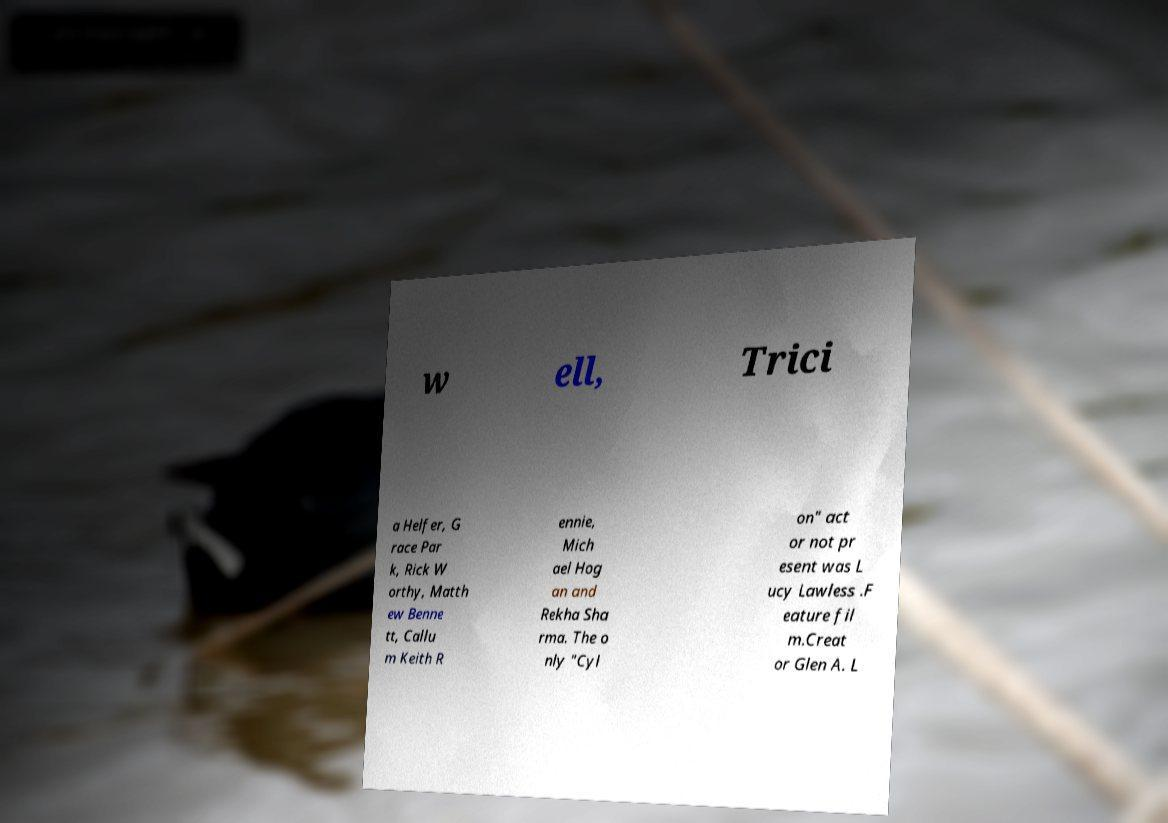Can you accurately transcribe the text from the provided image for me? w ell, Trici a Helfer, G race Par k, Rick W orthy, Matth ew Benne tt, Callu m Keith R ennie, Mich ael Hog an and Rekha Sha rma. The o nly "Cyl on" act or not pr esent was L ucy Lawless .F eature fil m.Creat or Glen A. L 